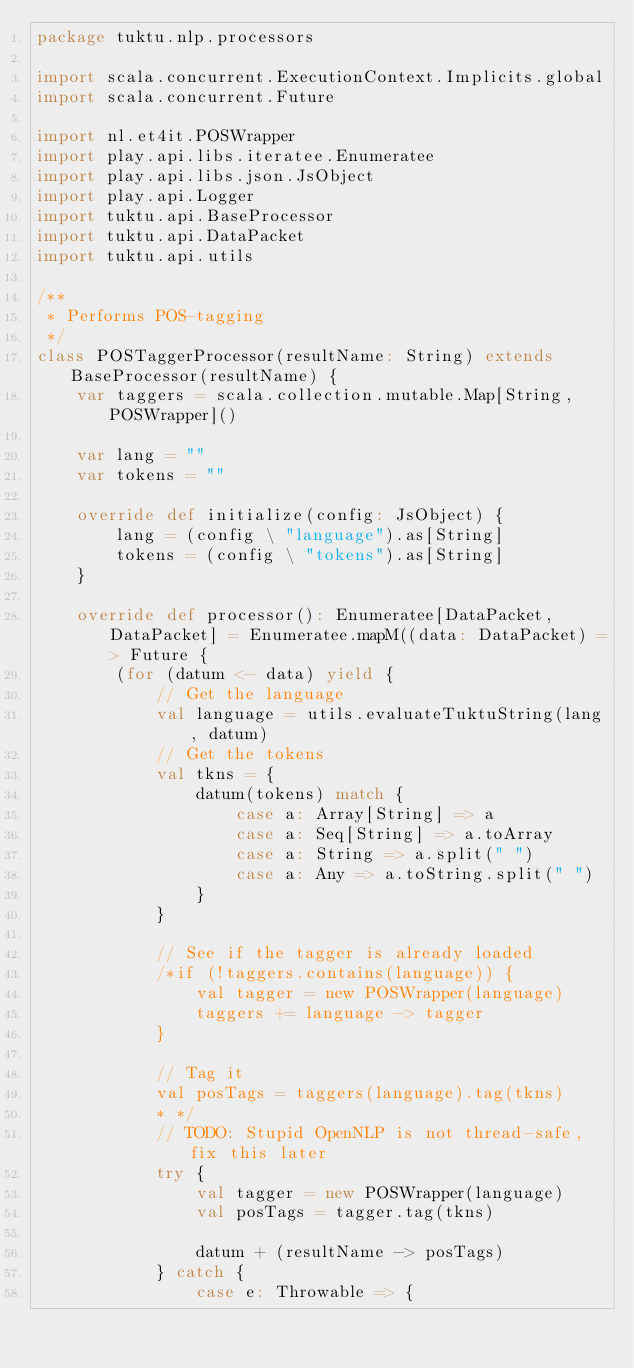<code> <loc_0><loc_0><loc_500><loc_500><_Scala_>package tuktu.nlp.processors

import scala.concurrent.ExecutionContext.Implicits.global
import scala.concurrent.Future

import nl.et4it.POSWrapper
import play.api.libs.iteratee.Enumeratee
import play.api.libs.json.JsObject
import play.api.Logger
import tuktu.api.BaseProcessor
import tuktu.api.DataPacket
import tuktu.api.utils

/**
 * Performs POS-tagging
 */
class POSTaggerProcessor(resultName: String) extends BaseProcessor(resultName) {
    var taggers = scala.collection.mutable.Map[String, POSWrapper]()

    var lang = ""
    var tokens = ""

    override def initialize(config: JsObject) {
        lang = (config \ "language").as[String]
        tokens = (config \ "tokens").as[String]
    }

    override def processor(): Enumeratee[DataPacket, DataPacket] = Enumeratee.mapM((data: DataPacket) => Future {
        (for (datum <- data) yield {
            // Get the language
            val language = utils.evaluateTuktuString(lang, datum)
            // Get the tokens
            val tkns = {
                datum(tokens) match {
                    case a: Array[String] => a
                    case a: Seq[String] => a.toArray
                    case a: String => a.split(" ")
                    case a: Any => a.toString.split(" ")
                }
            }

            // See if the tagger is already loaded
            /*if (!taggers.contains(language)) {
                val tagger = new POSWrapper(language)
                taggers += language -> tagger
            }
            
            // Tag it
            val posTags = taggers(language).tag(tkns)
            * */
            // TODO: Stupid OpenNLP is not thread-safe, fix this later
            try {
                val tagger = new POSWrapper(language)
                val posTags = tagger.tag(tkns)

                datum + (resultName -> posTags)
            } catch {
                case e: Throwable => {</code> 